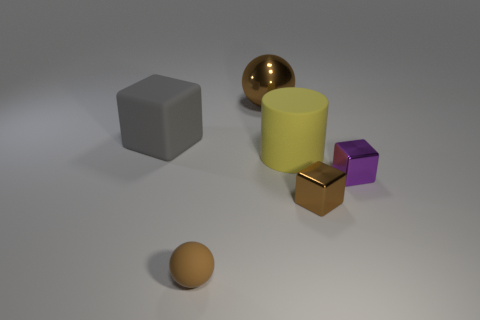There is a large matte thing to the right of the ball in front of the brown metal cube; how many brown rubber objects are behind it?
Provide a short and direct response. 0. Is there any other thing that has the same color as the small matte object?
Give a very brief answer. Yes. Do the thing that is left of the small brown rubber object and the big matte object in front of the large gray block have the same color?
Provide a succinct answer. No. Is the number of small purple metallic cubes that are to the left of the rubber sphere greater than the number of big brown things that are on the right side of the large brown thing?
Your answer should be very brief. No. What material is the purple object?
Make the answer very short. Metal. The tiny thing that is on the right side of the small brown block on the right side of the brown sphere behind the gray block is what shape?
Offer a terse response. Cube. What number of other objects are there of the same material as the large brown ball?
Provide a short and direct response. 2. Do the brown sphere that is behind the yellow cylinder and the ball that is in front of the matte cube have the same material?
Ensure brevity in your answer.  No. How many objects are both on the left side of the big yellow cylinder and in front of the big yellow cylinder?
Your answer should be compact. 1. Is there a brown thing of the same shape as the purple metal object?
Give a very brief answer. Yes. 